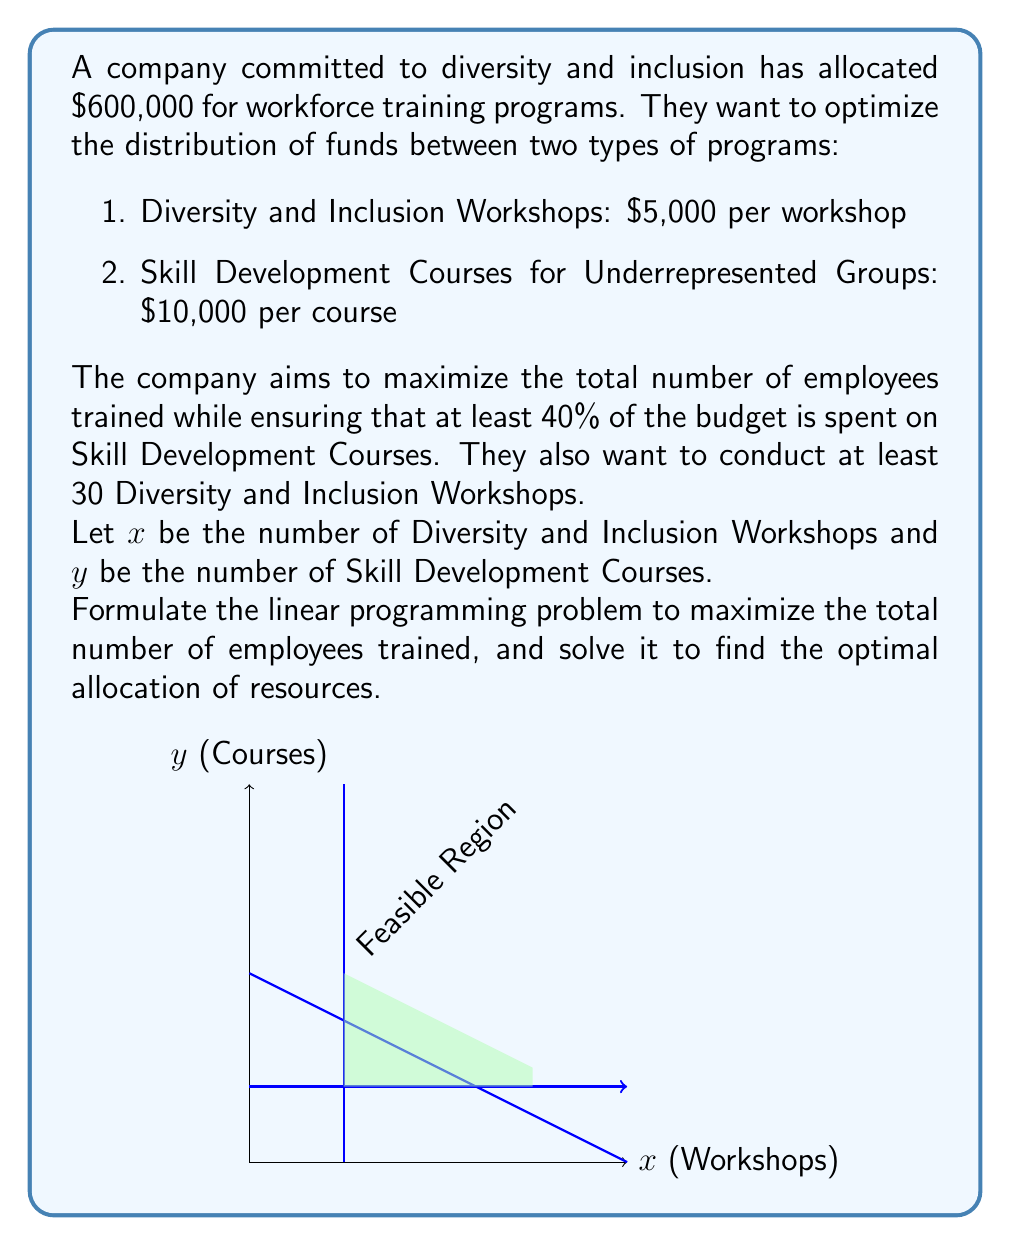Can you answer this question? Let's approach this step-by-step:

1) Objective function:
   We want to maximize the total number of employees trained:
   $$\text{Maximize } Z = x + y$$

2) Constraints:
   a) Budget constraint: 
      $$5000x + 10000y \leq 600000$$
      Simplifying: $$5x + 10y \leq 600$$
   
   b) At least 40% of budget on Skill Development Courses:
      $$10000y \geq 0.4(600000)$$
      Simplifying: $$y \geq 24$$
   
   c) At least 30 Diversity and Inclusion Workshops:
      $$x \geq 30$$
   
   d) Non-negativity constraints:
      $$x \geq 0, y \geq 0$$

3) Solving graphically:
   - The feasible region is bounded by the lines from constraints a, b, and c.
   - The optimal solution will be at one of the corner points of this region.

4) Corner points:
   - (30, 24)
   - (30, 60)
   - (90, 30)

5) Evaluating Z at each point:
   - Z(30, 24) = 54
   - Z(30, 60) = 90
   - Z(90, 30) = 120

6) The maximum value of Z occurs at (90, 30).

Therefore, the optimal solution is to conduct 90 Diversity and Inclusion Workshops and 30 Skill Development Courses, training a total of 120 employees.
Answer: 90 Workshops, 30 Courses 